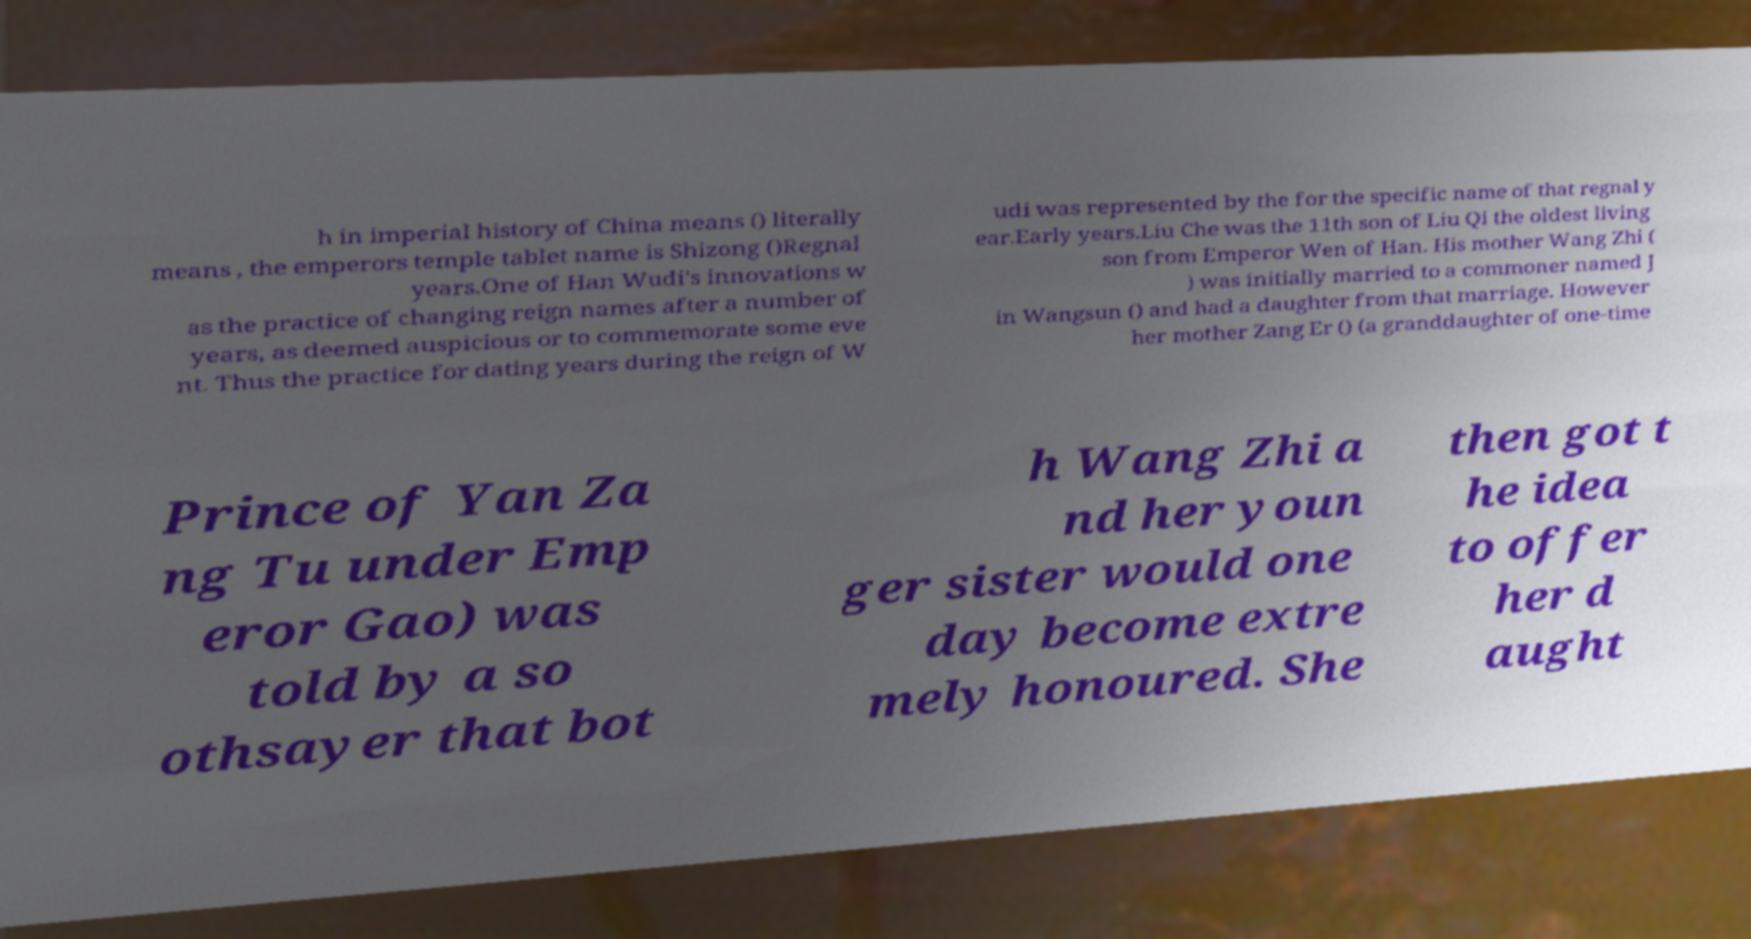Could you assist in decoding the text presented in this image and type it out clearly? h in imperial history of China means () literally means , the emperors temple tablet name is Shizong ()Regnal years.One of Han Wudi's innovations w as the practice of changing reign names after a number of years, as deemed auspicious or to commemorate some eve nt. Thus the practice for dating years during the reign of W udi was represented by the for the specific name of that regnal y ear.Early years.Liu Che was the 11th son of Liu Qi the oldest living son from Emperor Wen of Han. His mother Wang Zhi ( ) was initially married to a commoner named J in Wangsun () and had a daughter from that marriage. However her mother Zang Er () (a granddaughter of one-time Prince of Yan Za ng Tu under Emp eror Gao) was told by a so othsayer that bot h Wang Zhi a nd her youn ger sister would one day become extre mely honoured. She then got t he idea to offer her d aught 